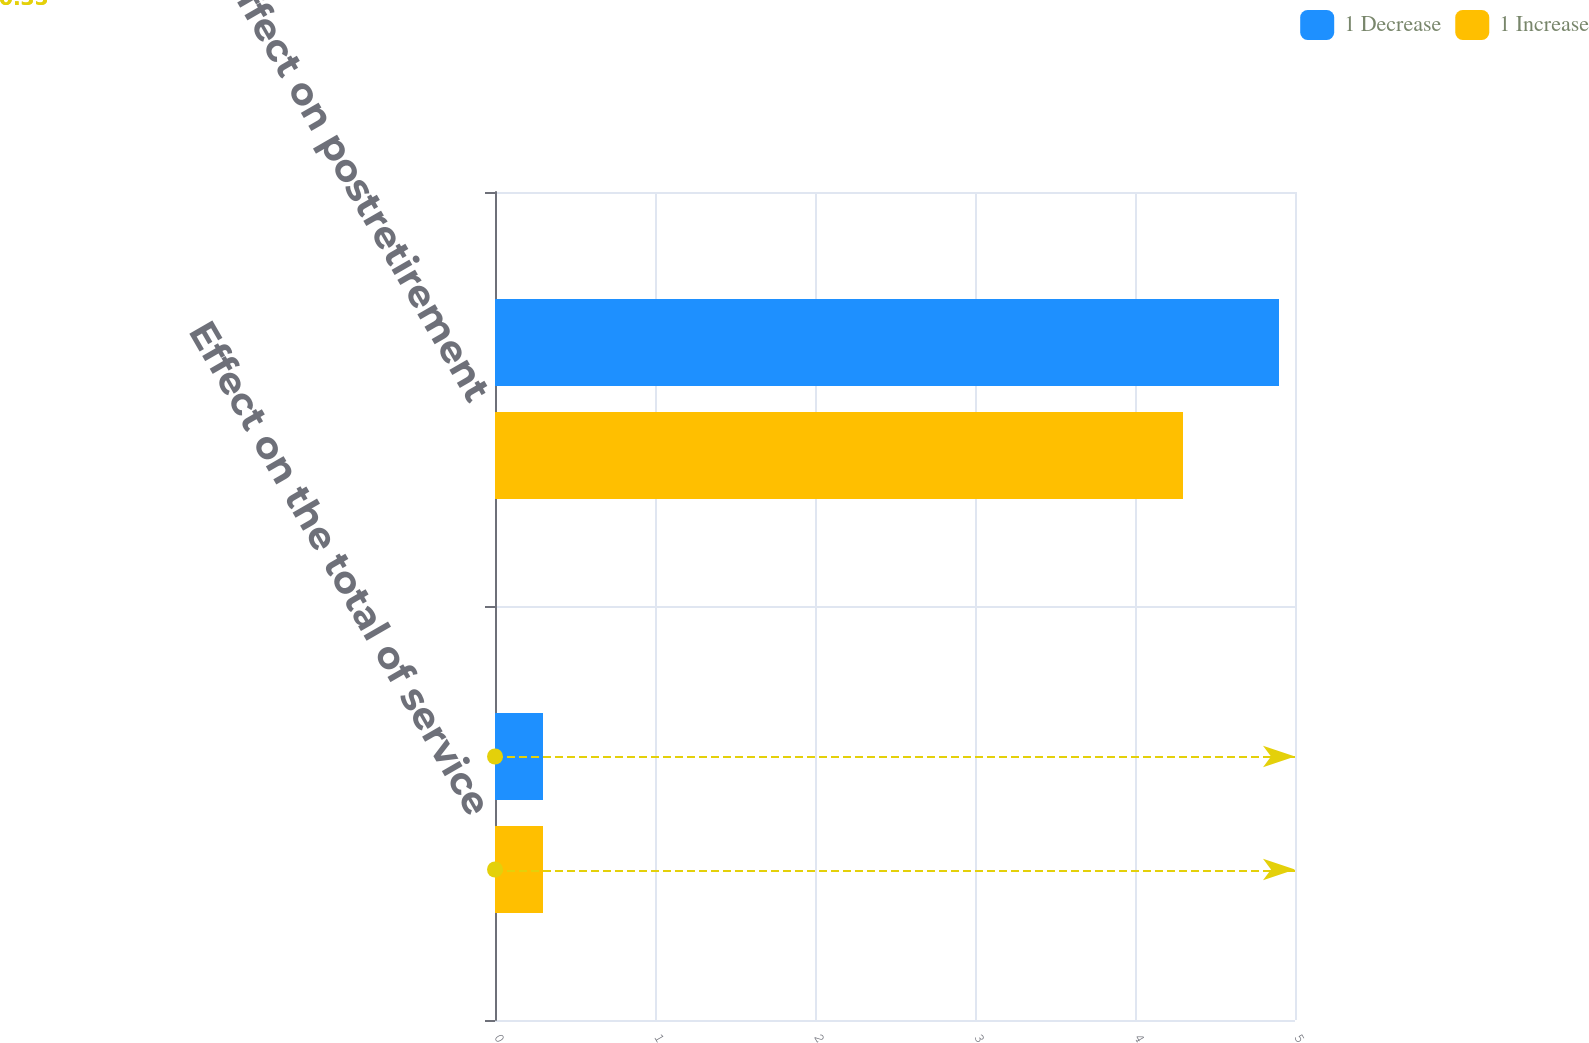Convert chart. <chart><loc_0><loc_0><loc_500><loc_500><stacked_bar_chart><ecel><fcel>Effect on the total of service<fcel>Effect on postretirement<nl><fcel>1 Decrease<fcel>0.3<fcel>4.9<nl><fcel>1 Increase<fcel>0.3<fcel>4.3<nl></chart> 